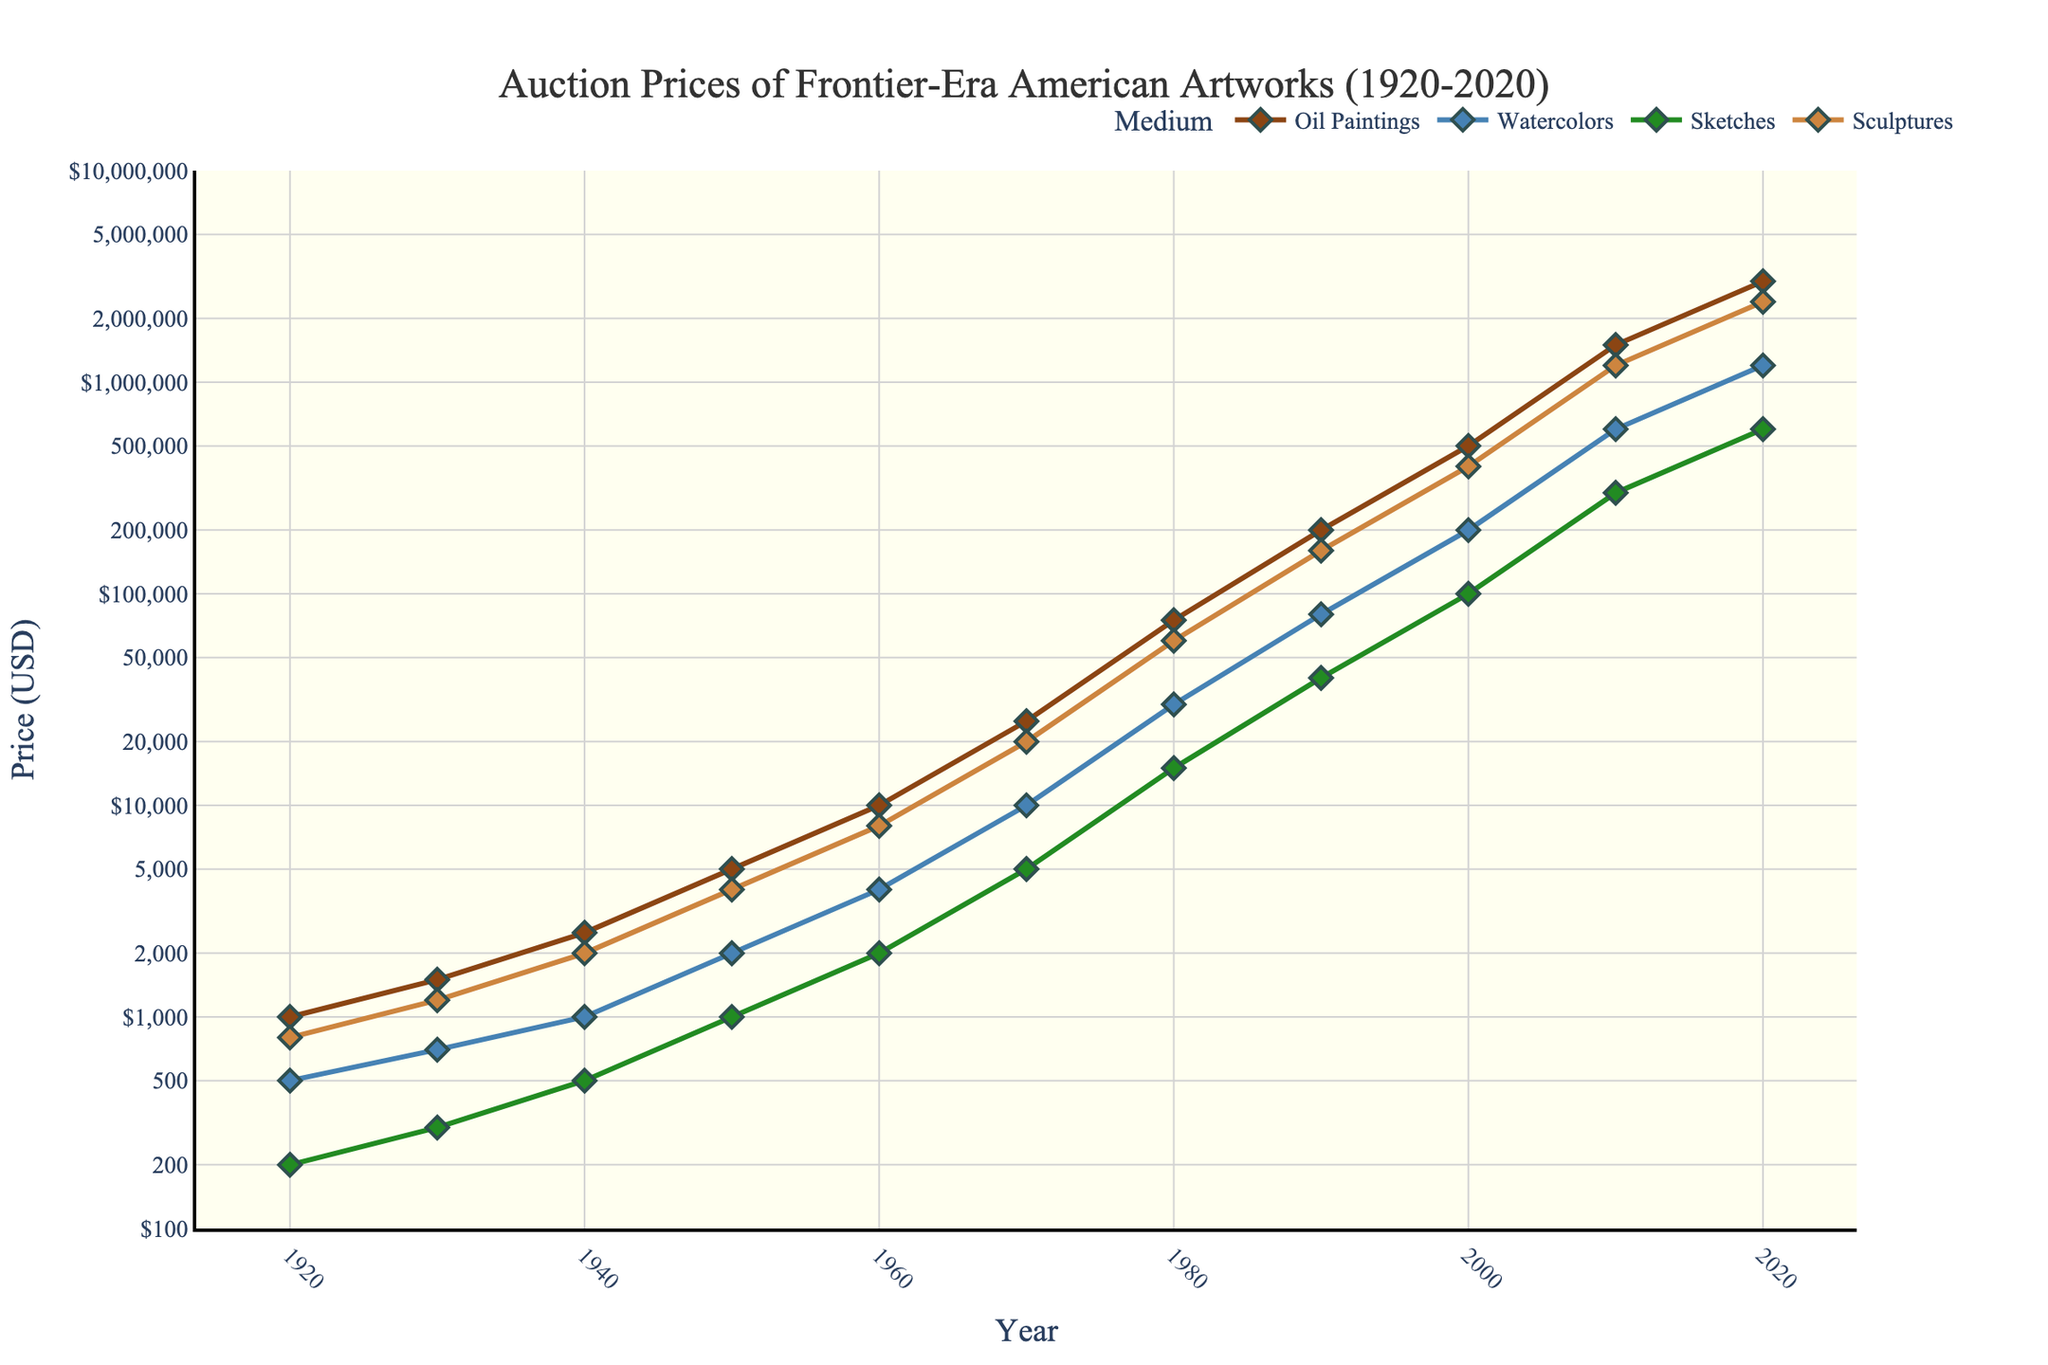What was the price difference of Oil Paintings between 1940 and 1980? To find the price difference, locate Oil Paintings' prices in 1940 and 1980. In 1940, it was $2,500, and in 1980, it was $75,000. Subtracting these gives $75,000 - $2,500 = $72,500.
Answer: $72,500 Which medium had the highest auction price in 2020? To determine the highest auction price in 2020, compare the final values of all media. Oil Paintings were $3,000,000; Watercolors were $1,200,000; Sketches were $600,000; Sculptures were $2,400,000. The highest value is for Oil Paintings at $3,000,000.
Answer: Oil Paintings By how much did the average price of Sculptures increase from 1960 to 2010? Calculate the average rate of increase by considering the prices in 1960 and 2010. In 1960, Sculptures were $8,000, and in 2010, they were $1,200,000. The increase is $1,200,000 - $8,000 = $1,192,000. Spread over the 50 years, the average annual increase is $1,192,000 / 50 ≈ $23,840.
Answer: $23,840 Between which years did Watercolors show the most significant price increase? To find the period with the most significant increase, compute the differences between each decade. Significant jumps are as follows: 1920-1930: $200, 1930-1940: $300, 1940-1950: $1,000, 1950-1960: $2,000, 1960-1970: $6,000, 1970-1980: $20,000, 1980-1990: $50,000, 1990-2000: $120,000, 2000-2010: $400,000, 2010-2020: $600,000. Notice the most significant jump between 2000 and 2010 which is $400,000.
Answer: 2000 and 2010 Which medium's auction prices grew the least from 1920 to 2020? Calculate the growth for each medium: Oil Paintings grew by $3,000,000 - $1,000 = $2,999,000; Watercolors grew by $1,200,000 - $500 = $1,199,500; Sketches grew by $600,000 - $200 = $599,800; Sculptures grew by $2,400,000 - $800 = $2,399,200. Sketches had the smallest growth of $599,800.
Answer: Sketches 